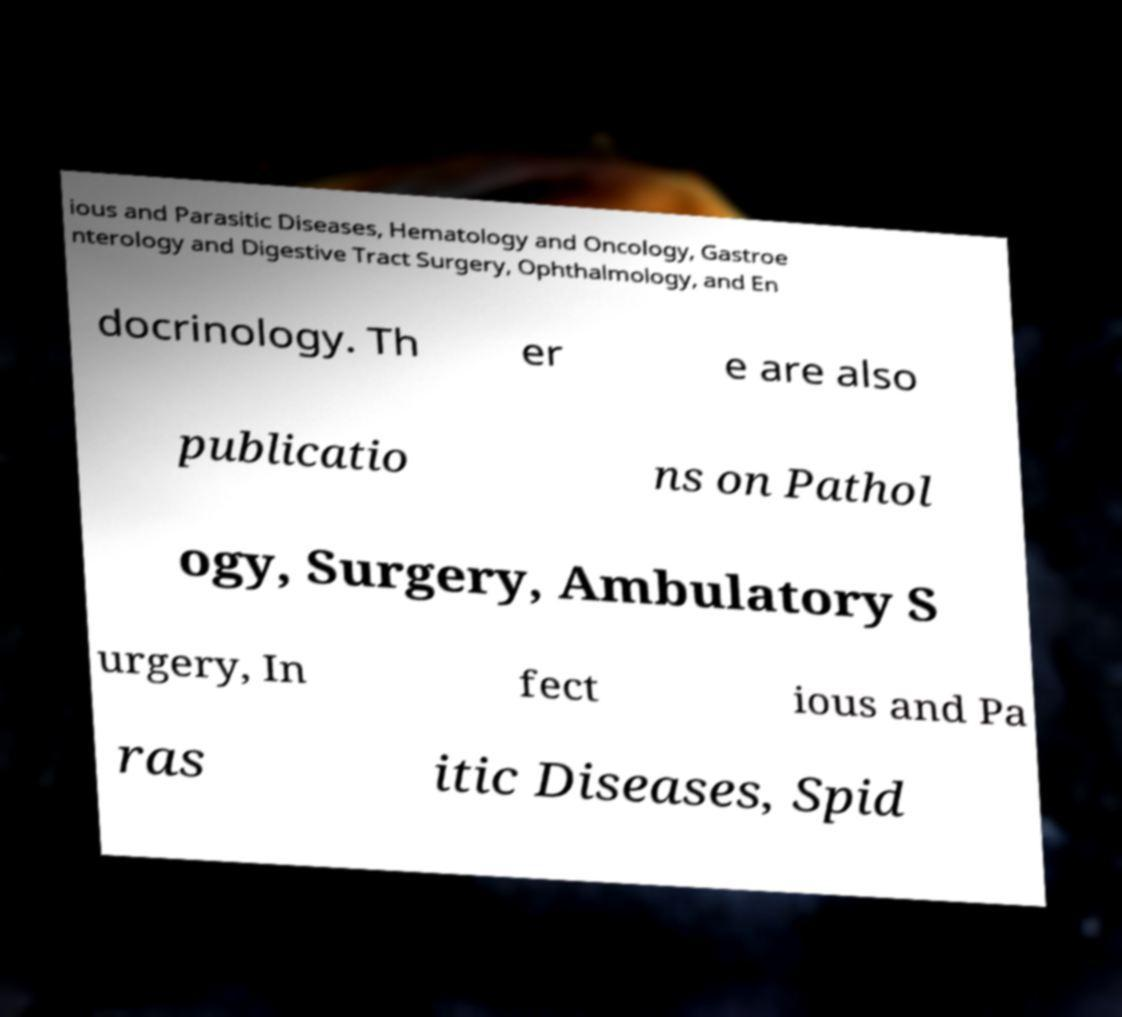There's text embedded in this image that I need extracted. Can you transcribe it verbatim? ious and Parasitic Diseases, Hematology and Oncology, Gastroe nterology and Digestive Tract Surgery, Ophthalmology, and En docrinology. Th er e are also publicatio ns on Pathol ogy, Surgery, Ambulatory S urgery, In fect ious and Pa ras itic Diseases, Spid 